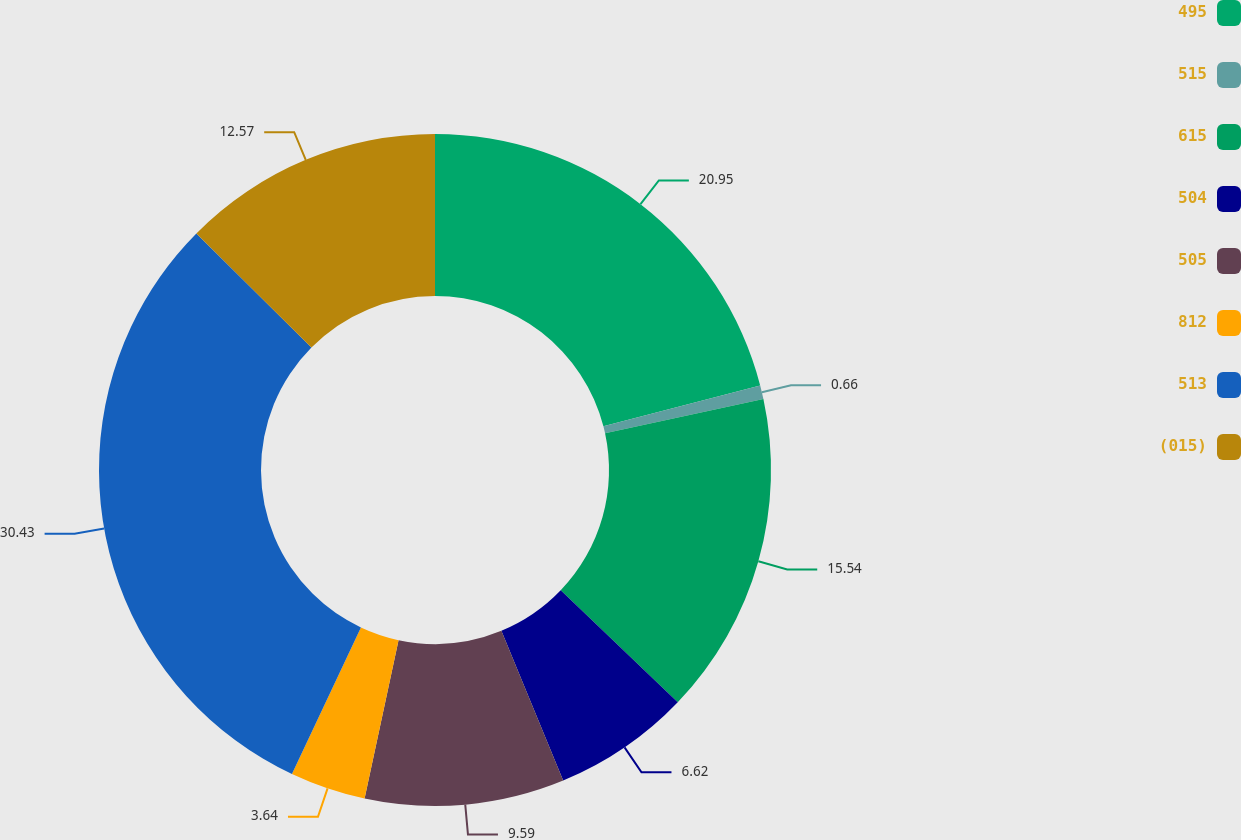<chart> <loc_0><loc_0><loc_500><loc_500><pie_chart><fcel>495<fcel>515<fcel>615<fcel>504<fcel>505<fcel>812<fcel>513<fcel>(015)<nl><fcel>20.95%<fcel>0.66%<fcel>15.54%<fcel>6.62%<fcel>9.59%<fcel>3.64%<fcel>30.43%<fcel>12.57%<nl></chart> 